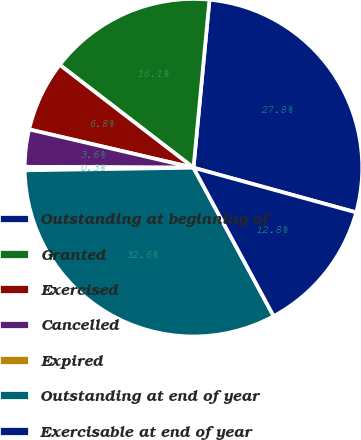Convert chart. <chart><loc_0><loc_0><loc_500><loc_500><pie_chart><fcel>Outstanding at beginning of<fcel>Granted<fcel>Exercised<fcel>Cancelled<fcel>Expired<fcel>Outstanding at end of year<fcel>Exercisable at end of year<nl><fcel>27.76%<fcel>16.08%<fcel>6.79%<fcel>3.56%<fcel>0.33%<fcel>32.64%<fcel>12.85%<nl></chart> 